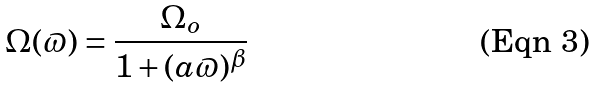Convert formula to latex. <formula><loc_0><loc_0><loc_500><loc_500>\Omega ( \varpi ) = \frac { \Omega _ { o } } { 1 + ( a \varpi ) ^ { \beta } }</formula> 